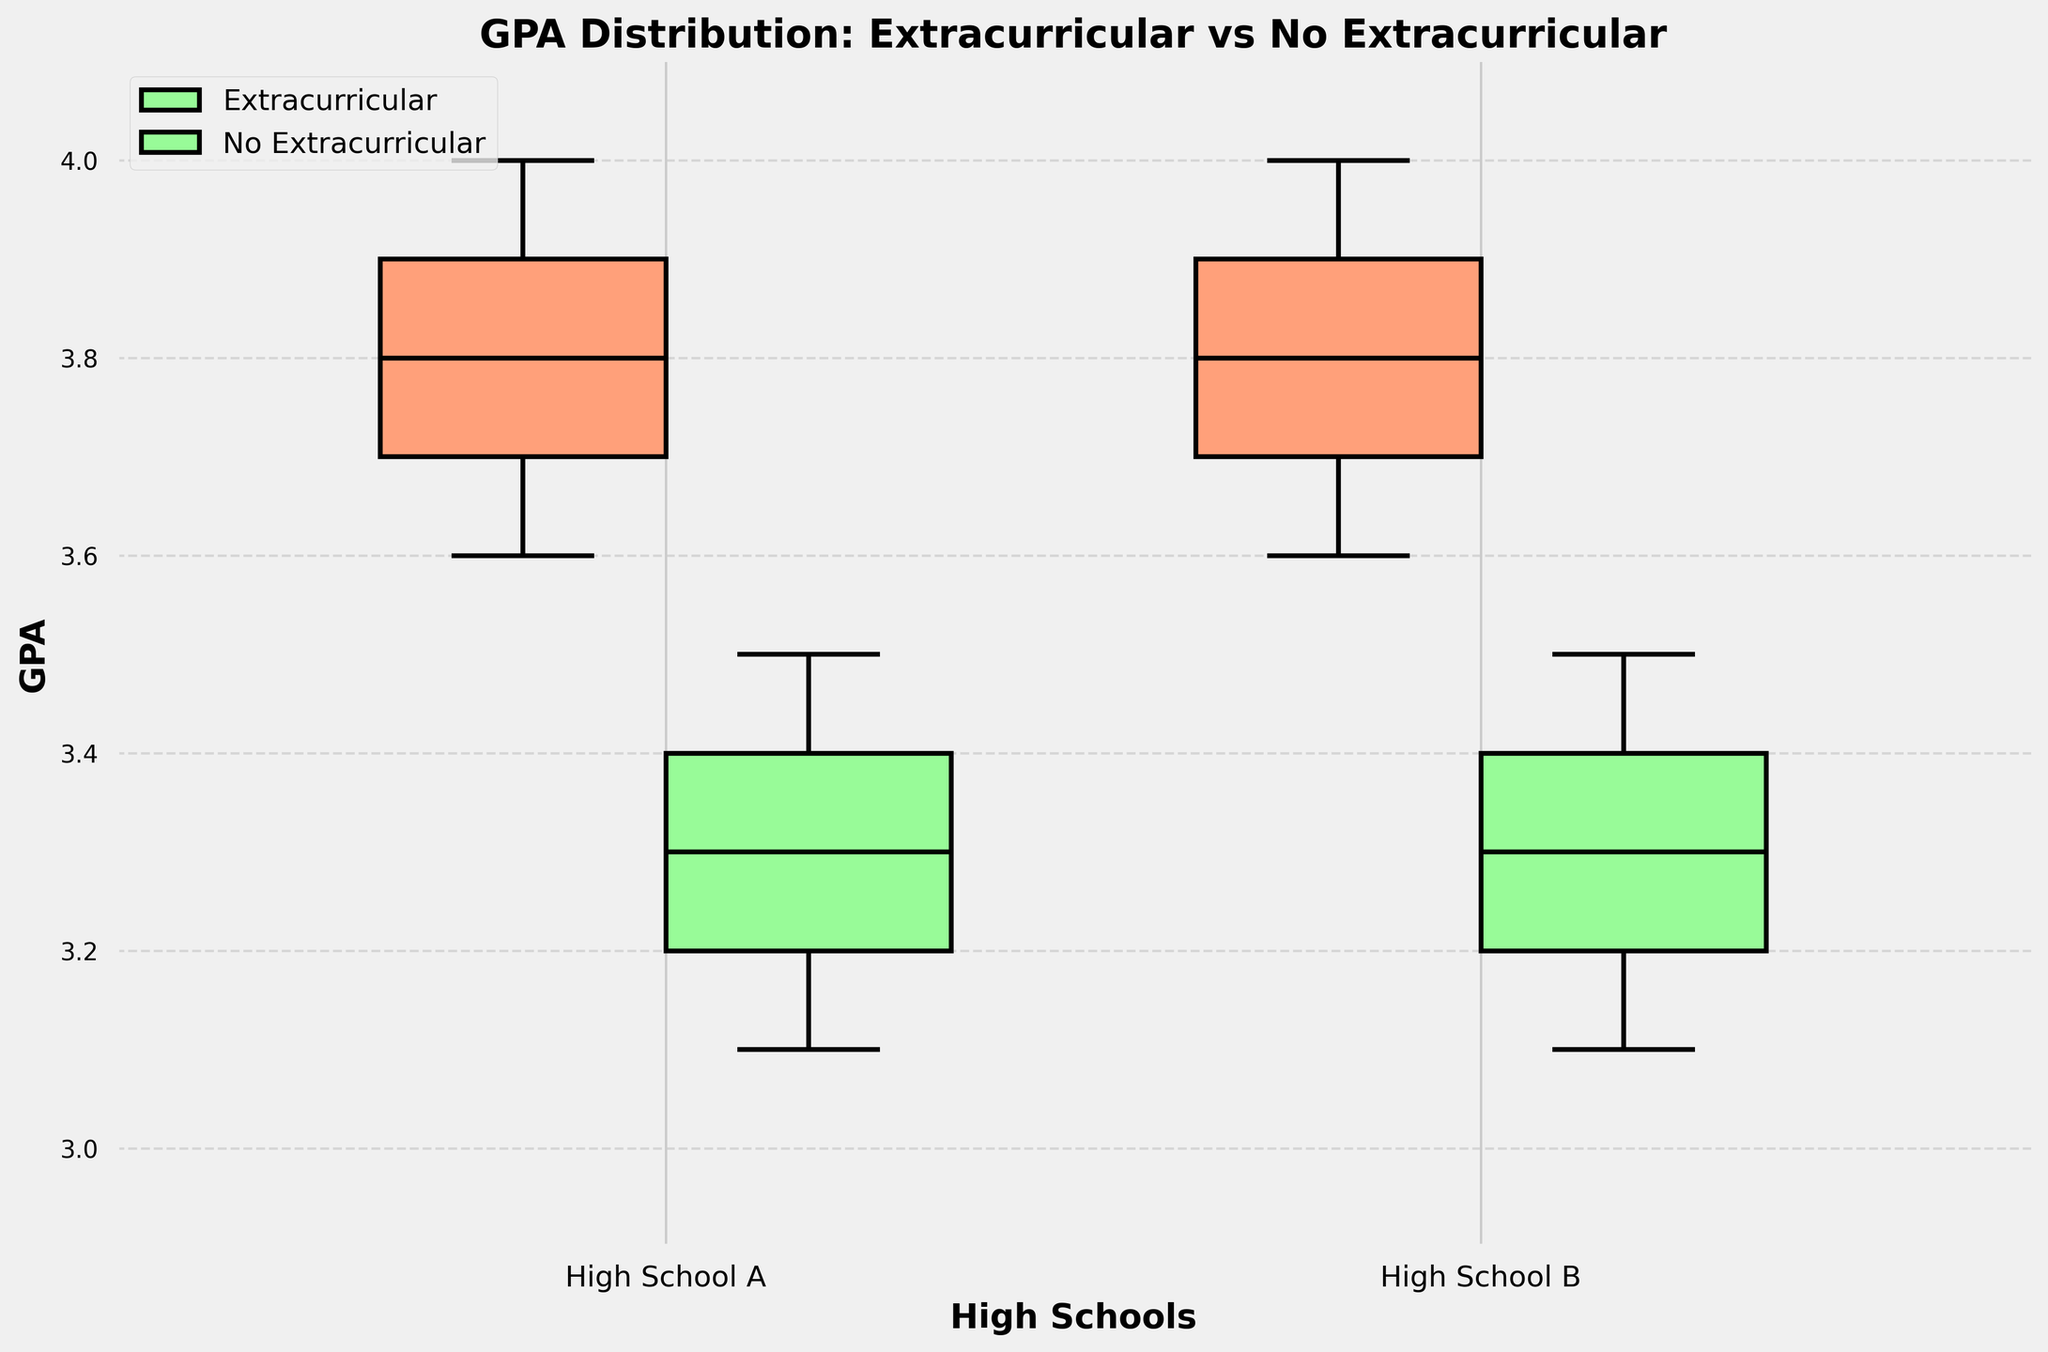What are the labels on the x-axis? The x-axis labels denote the names of the high schools being compared in the plot. These labels help us identify which data corresponds to each high school.
Answer: High School A, High School B What is the title of the grouped box plot? The title of the plot is positioned at the top and describes what is being visualized in the figure.
Answer: GPA Distribution: Extracurricular vs No Extracurricular Which activity group at High School A has a higher median GPA? By observing the center line within the boxes for High School A, we can compare the medians. The line inside the box represents the median of the group.
Answer: Extracurricular What is the color of the box representing students participating in extracurricular activities? The color of the boxes distinguishes between different groups. By looking at the legend, we can identify the color associated with extracurricular activities.
Answer: Orange (light salmon color) How does the interquartile range (IQR) for students not participating in extracurricular activities compare between High School A and High School B? The IQR is the range between the first quartile (Q1) and the third quartile (Q3). By comparing the lengths of the boxes for non-extracurricular activities at both schools, one can determine which has a larger IQR.
Answer: High School A has a larger IQR than High School B What is the minimum GPA for students participating in extracurricular activities at High School B? The minimum GPA is represented by the bottom whisker of each box. By locating this whisker for High School B's extracurricular activities group, the minimum value can be identified.
Answer: 3.6 Which school has a more consistent GPA distribution for students not participating in extracurricular activities? Consistency in distribution can be inferred from the spread of the data. A smaller range between the whiskers and fewer outliers indicate more consistency.
Answer: High School B Does participation in extracurricular activities seem to correlate with a higher GPA in both schools? By comparing the medians and overall distribution of GPAs for students with and without extracurricular activities at both schools, one can observe any apparent correlation.
Answer: Yes What is the difference in the median GPA of students participating in extracurricular activities between High School A and High School B? To find the difference, locate the median line in the boxes for the extracurricular groups in both schools and subtract the values.
Answer: High School A median is 3.8, High School B median is 3.8, so the difference is 0 